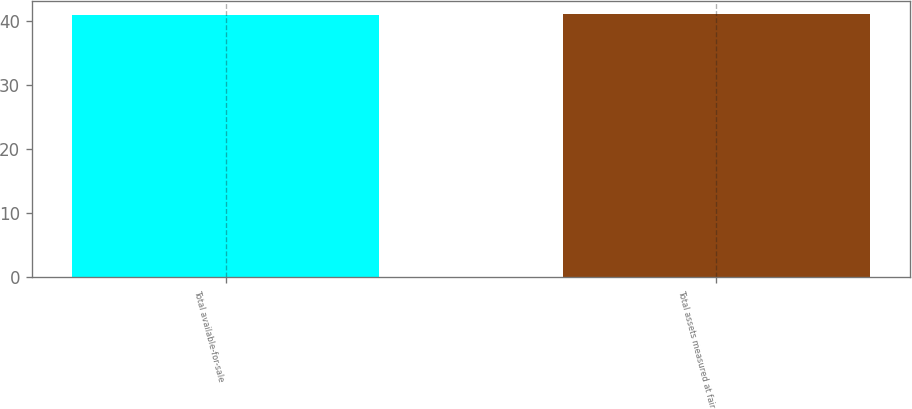Convert chart to OTSL. <chart><loc_0><loc_0><loc_500><loc_500><bar_chart><fcel>Total available-for-sale<fcel>Total assets measured at fair<nl><fcel>41<fcel>41.1<nl></chart> 